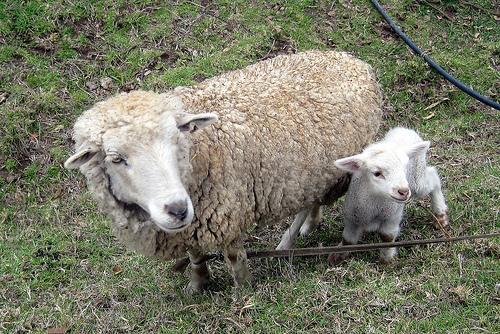How many baby sheep are there in the image?
Give a very brief answer. 1. 